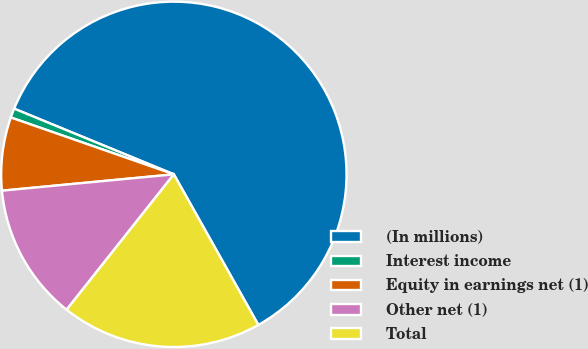Convert chart to OTSL. <chart><loc_0><loc_0><loc_500><loc_500><pie_chart><fcel>(In millions)<fcel>Interest income<fcel>Equity in earnings net (1)<fcel>Other net (1)<fcel>Total<nl><fcel>60.65%<fcel>0.87%<fcel>6.85%<fcel>12.83%<fcel>18.8%<nl></chart> 